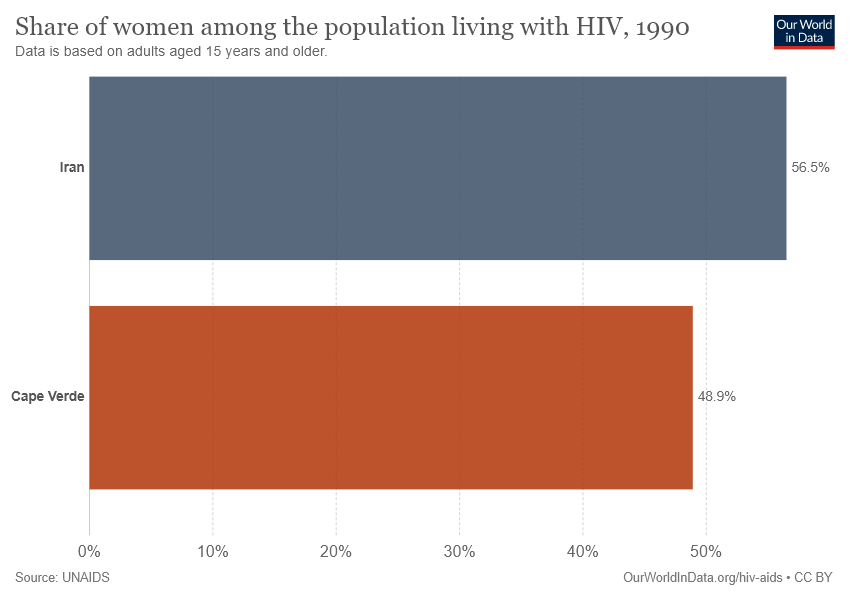Identify some key points in this picture. The ratio of Iran to Cape Verde is 0.15542..., which means that Iran is higher than Cape Verde by a significant margin. The country data shown in a gray color is Iran. 